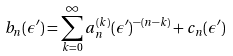<formula> <loc_0><loc_0><loc_500><loc_500>b _ { n } ( \epsilon ^ { \prime } ) = \sum _ { k = 0 } ^ { \infty } a _ { n } ^ { ( k ) } ( \epsilon ^ { \prime } ) ^ { - ( n - k ) } + c _ { n } ( \epsilon ^ { \prime } )</formula> 